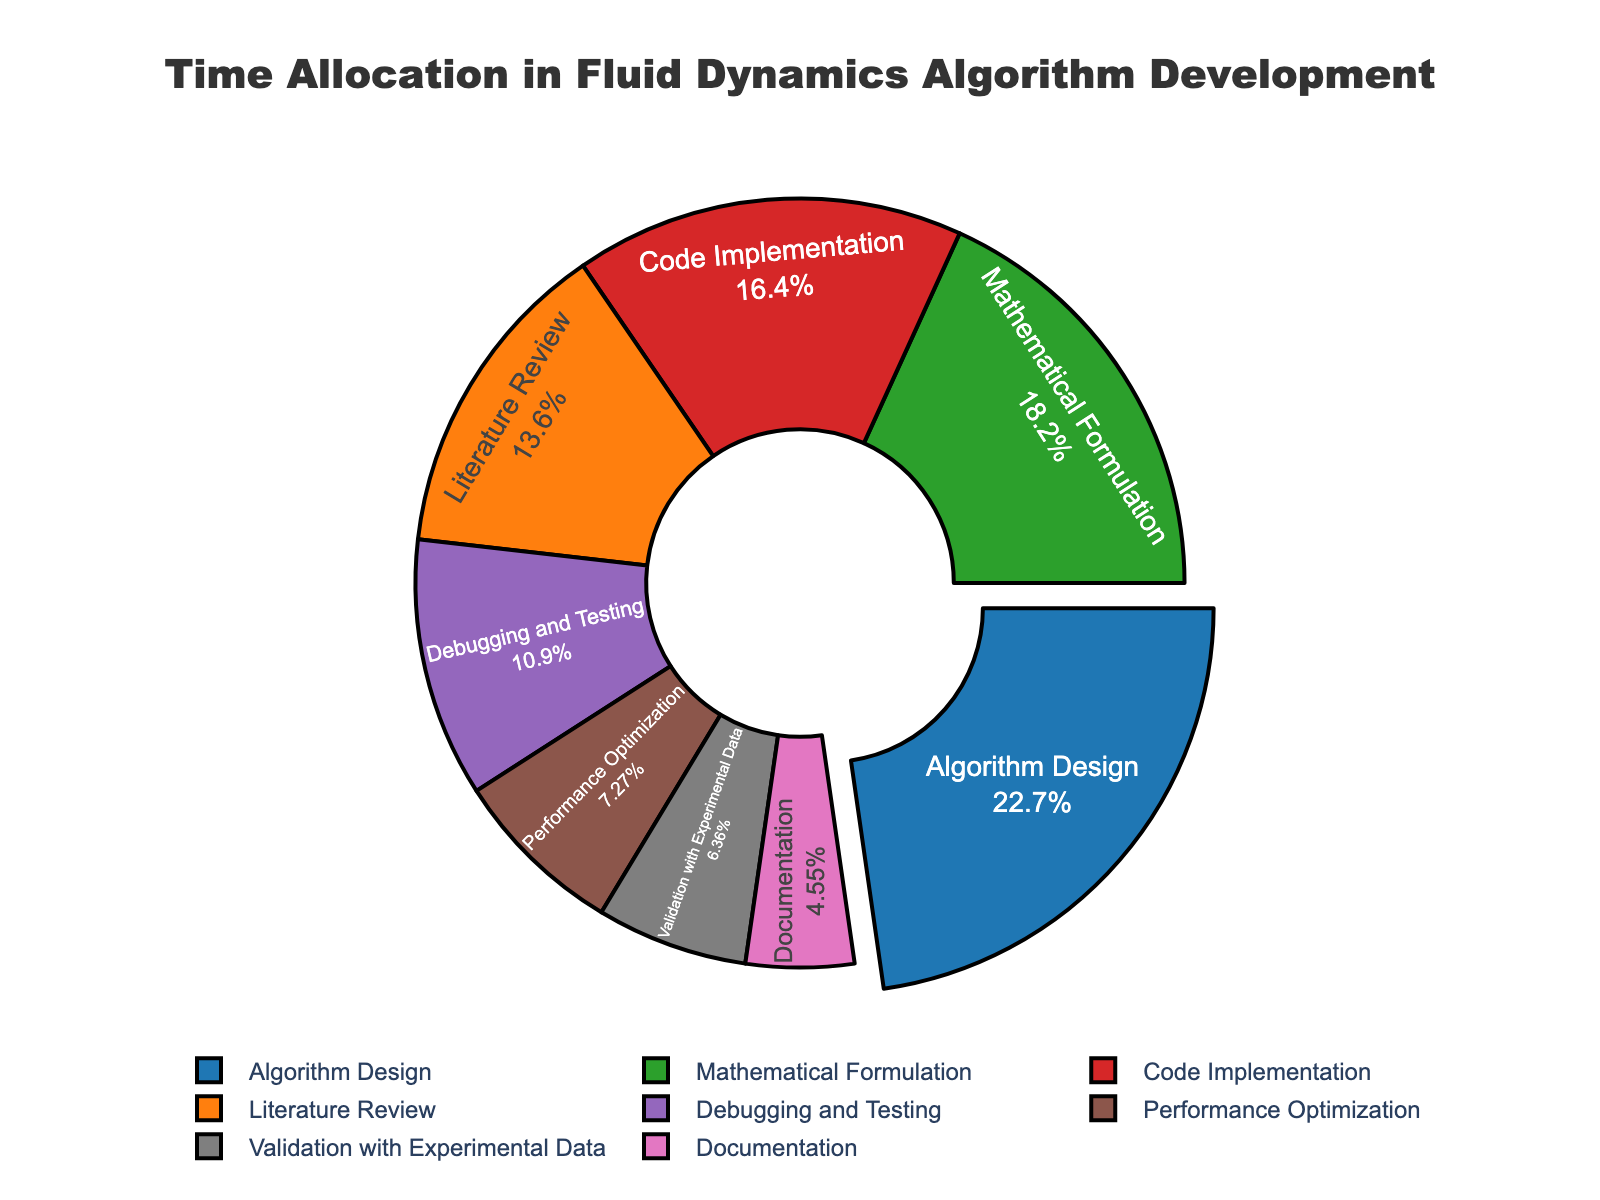What percentage of time is spent on Algorithm Design? The figure indicates that Algorithm Design takes up 25% of the total time.
Answer: 25% Which phase requires more time, Code Implementation or Debugging and Testing? The figure shows that Code Implementation has 18% and Debugging and Testing has 12%. Since 18 is greater than 12, Code Implementation requires more time.
Answer: Code Implementation What is the combined percentage of time spent on Mathematical Formulation and Performance Optimization? The figure shows 20% for Mathematical Formulation and 8% for Performance Optimization. Adding these together, 20 + 8 = 28%.
Answer: 28% Which phase is represented by the largest section of the pie chart? The figure shows various sections with their percentages clearly labeled. The largest percentage shown is for Algorithm Design at 25%.
Answer: Algorithm Design How much more time is spent on Literature Review compared to Documentation? The figure shows 15% for Literature Review and 5% for Documentation. The difference is 15% - 5% = 10%.
Answer: 10% Is the time allocated to Validation with Experimental Data higher or lower than Performance Optimization? The figure shows 7% for Validation with Experimental Data and 8% for Performance Optimization. Since 7% is less than 8%, Validation with Experimental Data is lower.
Answer: Lower What is the ratio of the time spent on Code Implementation to the time spent on Debugging and Testing? The figure shows 18% for Code Implementation and 12% for Debugging and Testing. The ratio is 18:12. Simplifying it, we get 3:2.
Answer: 3:2 What is the percentage of time spent on phases other than Algorithm Design? The figure shows Algorithm Design at 25%. Therefore, the percentage of time spent on other phases is 100% - 25% = 75%.
Answer: 75% How many phases have a time allocation less than 10%? The figure shows Performance Optimization at 8%, Documentation at 5%, and Validation with Experimental Data at 7%. These are the phases with less than 10%. There are 3 such phases.
Answer: 3 